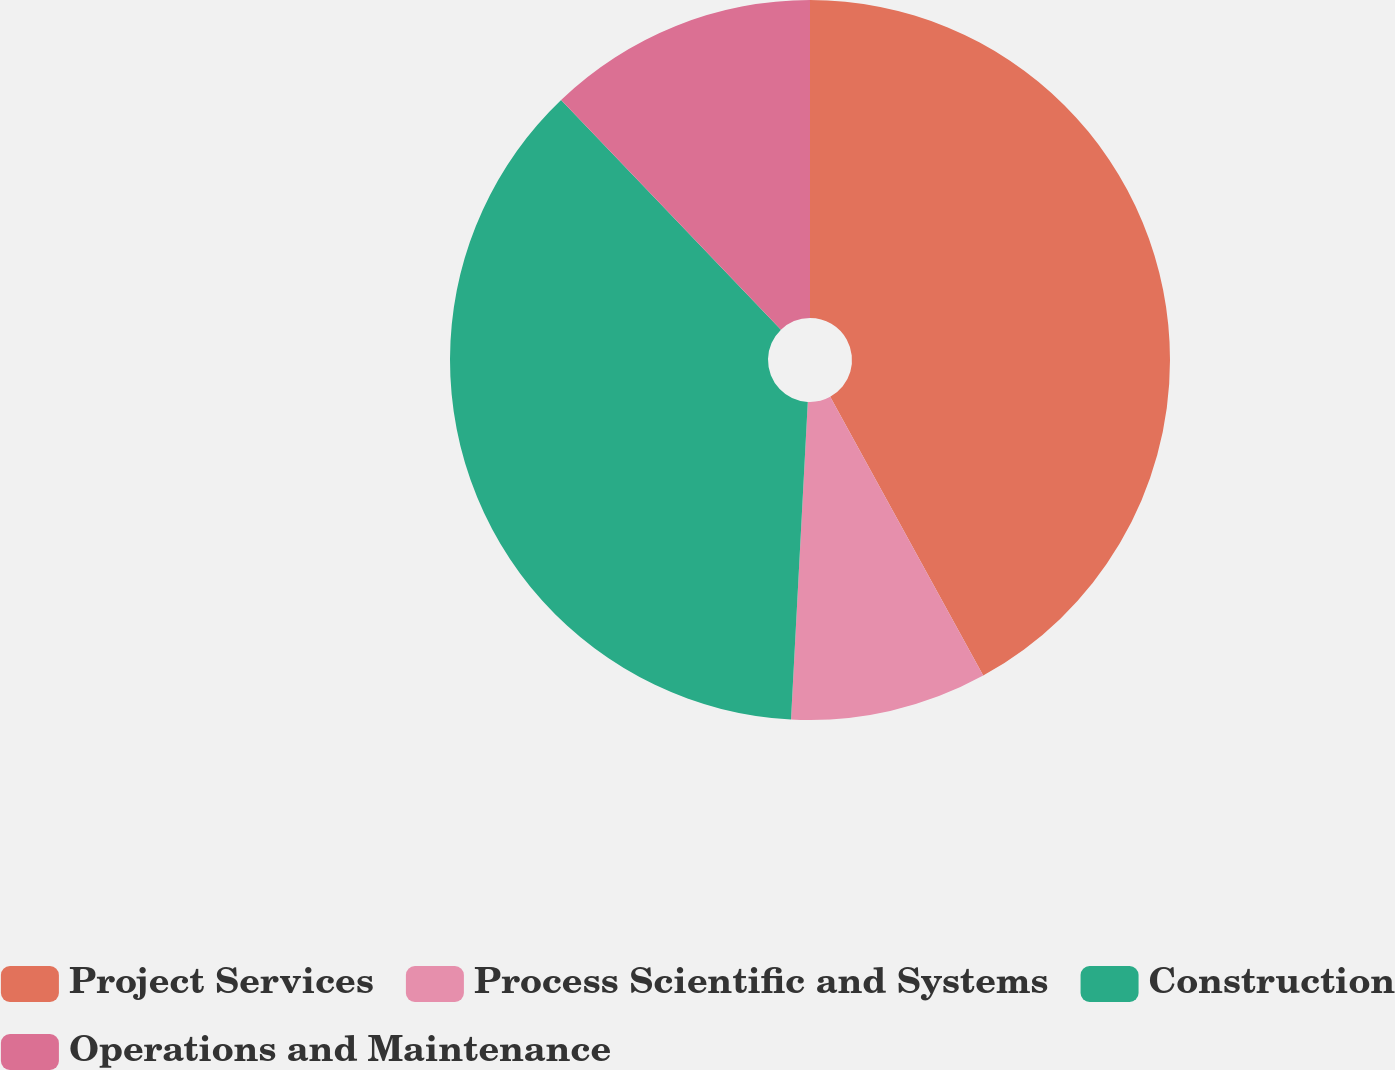Convert chart. <chart><loc_0><loc_0><loc_500><loc_500><pie_chart><fcel>Project Services<fcel>Process Scientific and Systems<fcel>Construction<fcel>Operations and Maintenance<nl><fcel>42.01%<fcel>8.83%<fcel>37.01%<fcel>12.15%<nl></chart> 